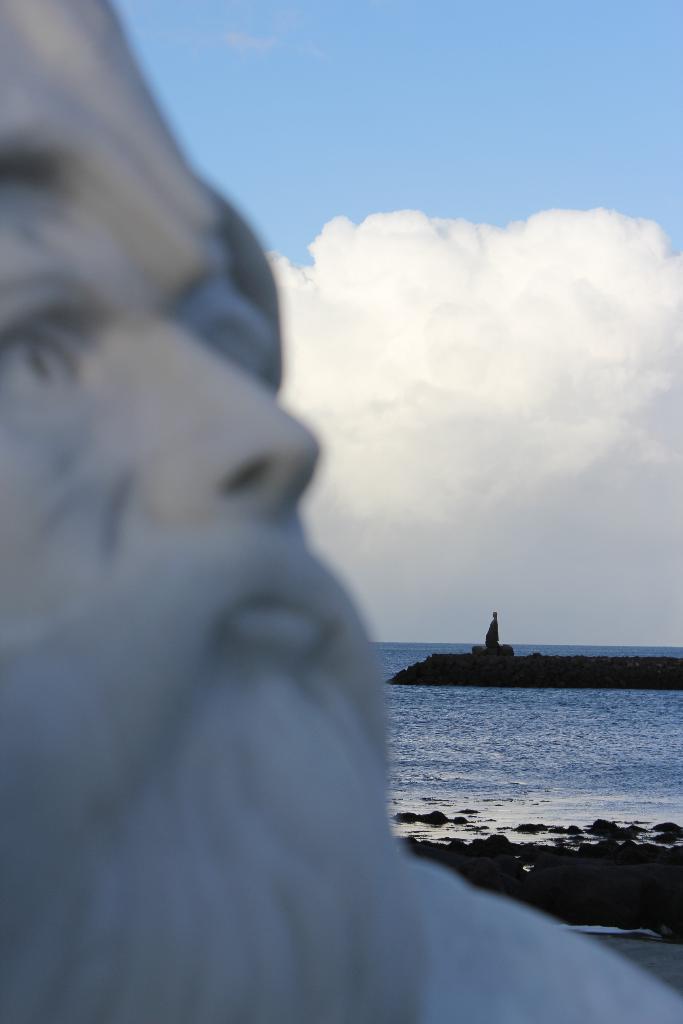Can you describe this image briefly? In this picture we can see a statue. There is water. Sky is blue in color. We can see an object on the left side. 